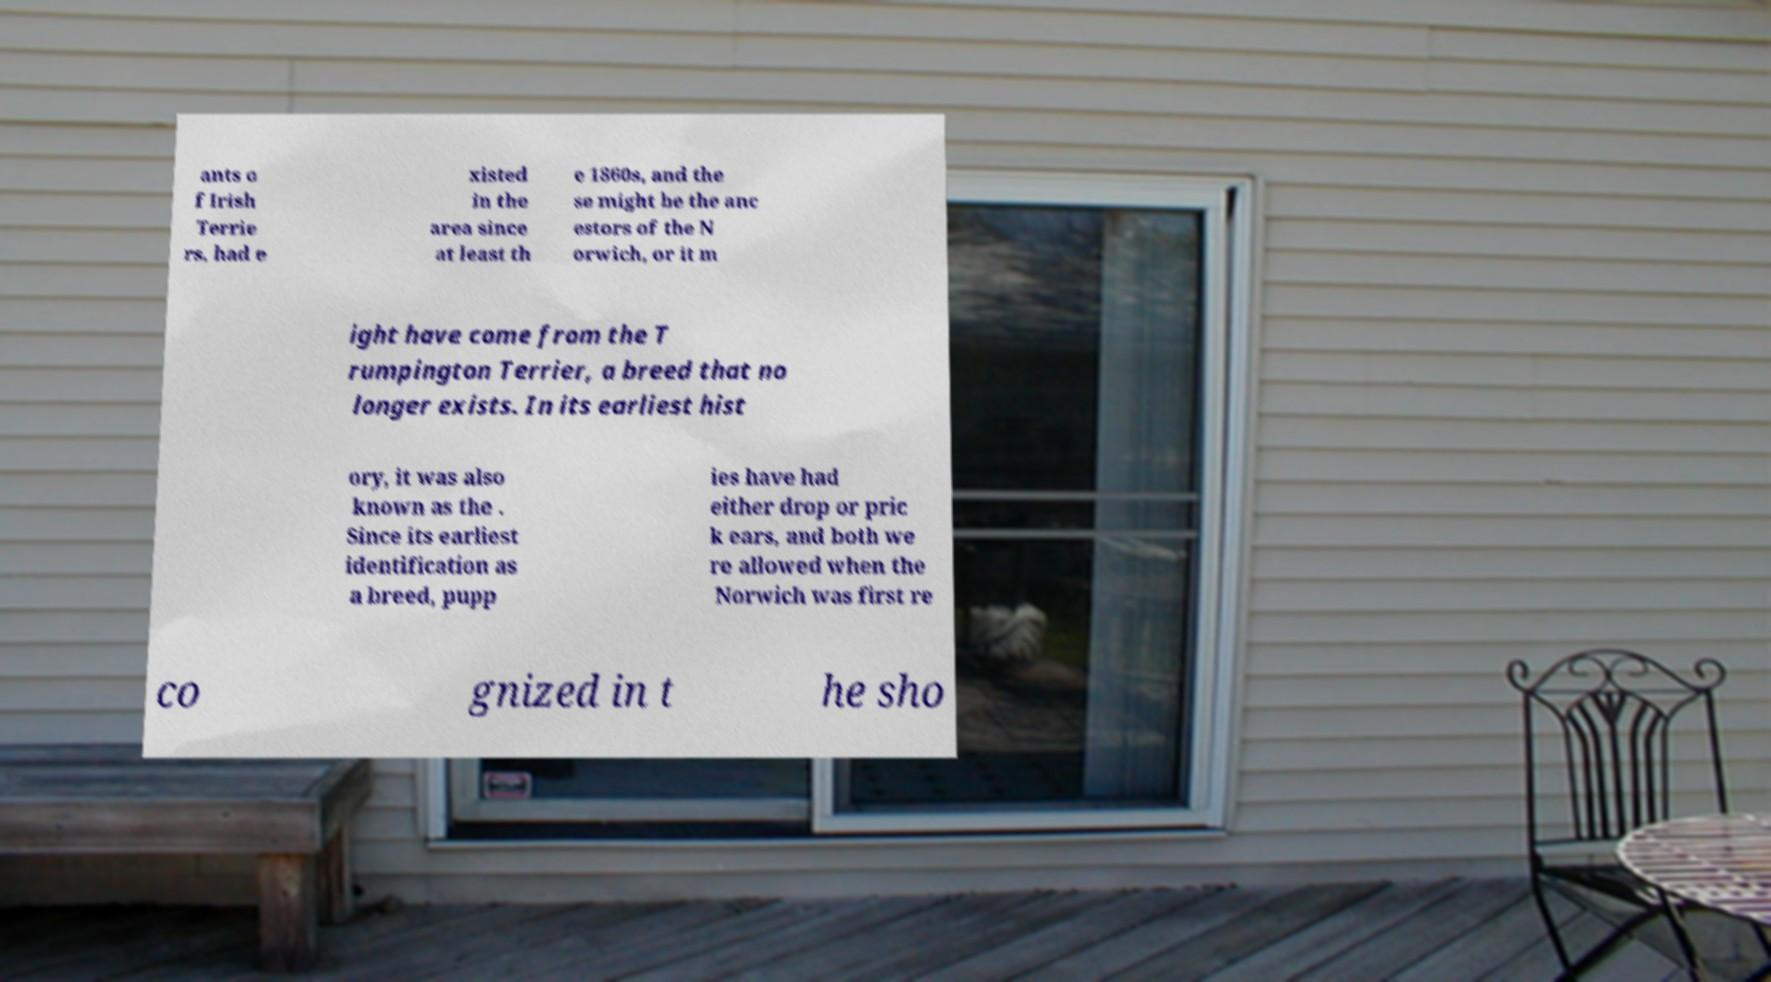For documentation purposes, I need the text within this image transcribed. Could you provide that? ants o f Irish Terrie rs, had e xisted in the area since at least th e 1860s, and the se might be the anc estors of the N orwich, or it m ight have come from the T rumpington Terrier, a breed that no longer exists. In its earliest hist ory, it was also known as the . Since its earliest identification as a breed, pupp ies have had either drop or pric k ears, and both we re allowed when the Norwich was first re co gnized in t he sho 